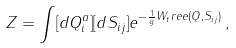<formula> <loc_0><loc_0><loc_500><loc_500>Z = \int [ d Q ^ { a } _ { i } ] [ d S _ { i j } ] e ^ { - \frac { 1 } { g } W _ { t } r e e ( Q , S _ { i j } ) } \, ,</formula> 